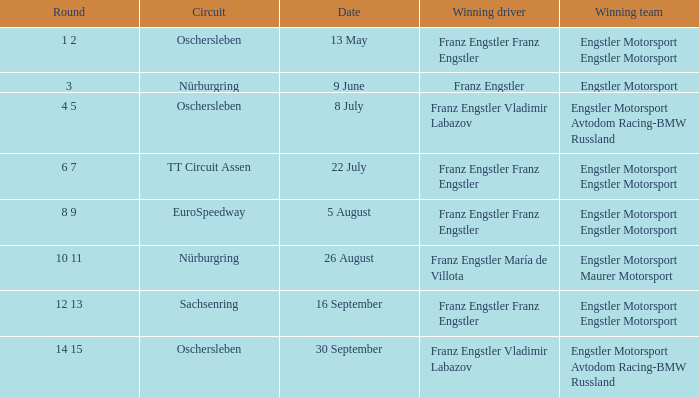For the date of 22 july, who is the successful team? Engstler Motorsport Engstler Motorsport. 